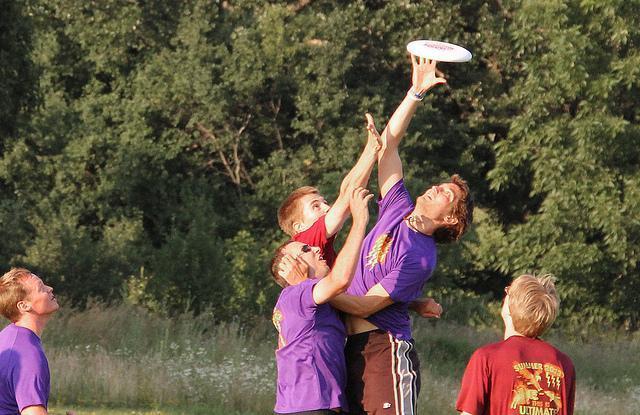How many people can be seen?
Give a very brief answer. 4. 